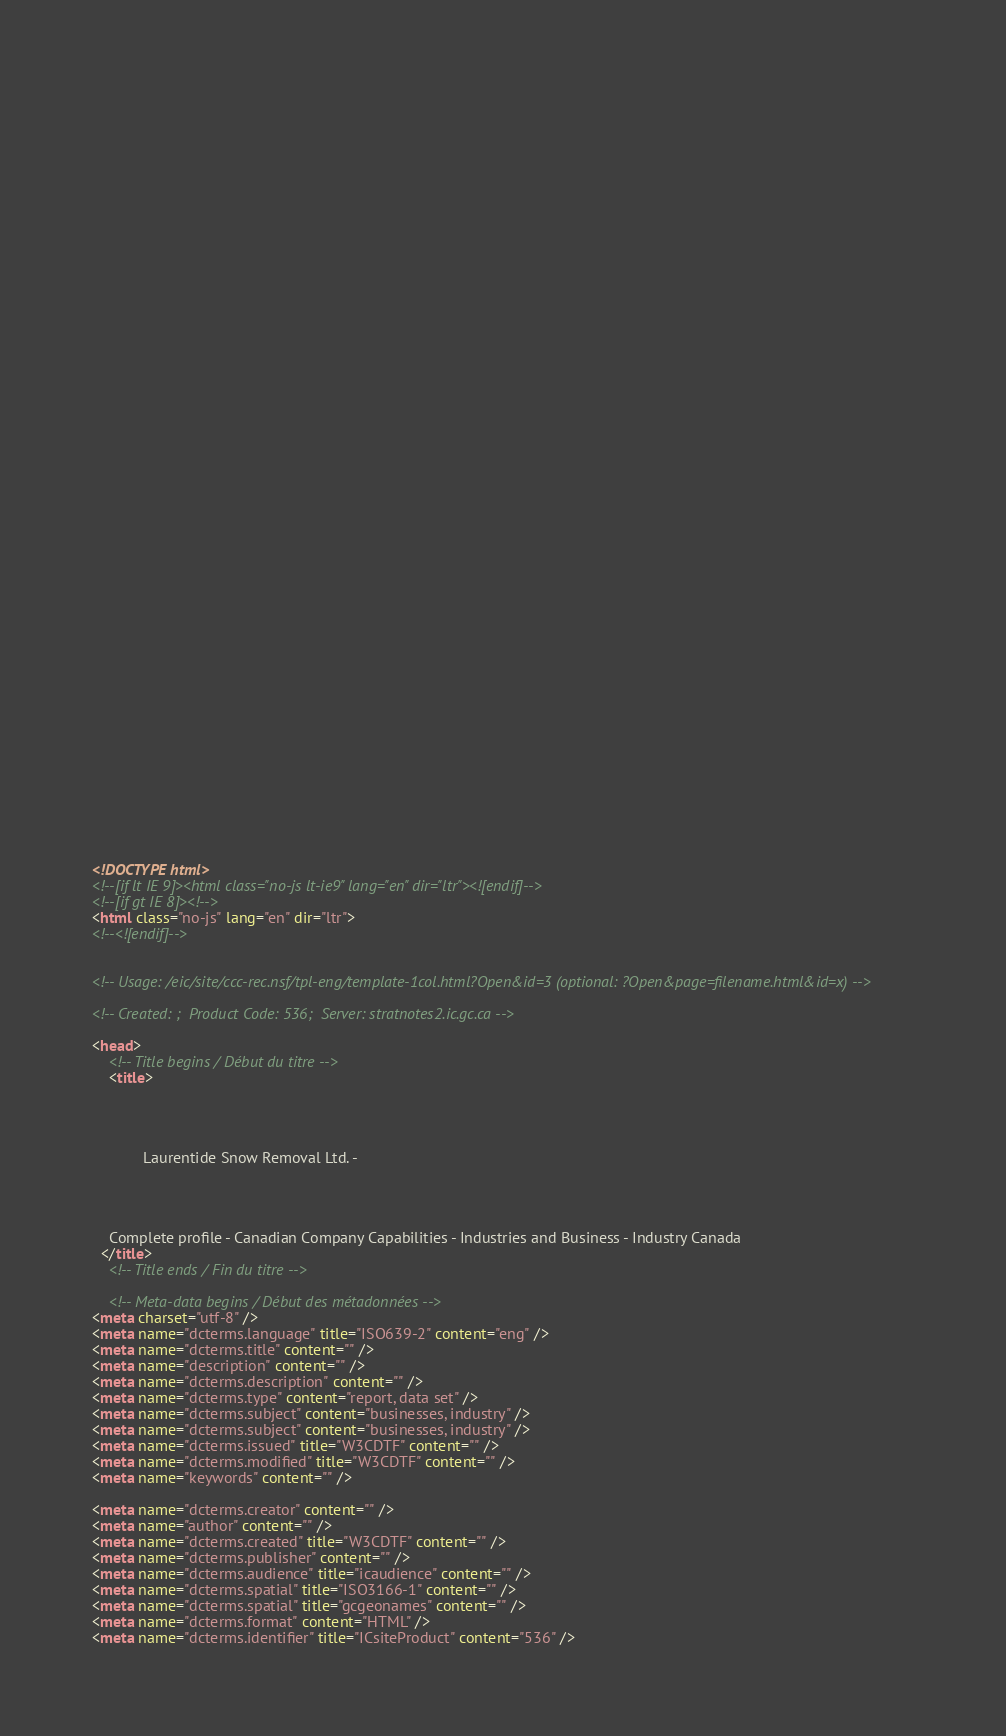<code> <loc_0><loc_0><loc_500><loc_500><_HTML_>


















	






  
  
  
  































	
	
	



<!DOCTYPE html>
<!--[if lt IE 9]><html class="no-js lt-ie9" lang="en" dir="ltr"><![endif]-->
<!--[if gt IE 8]><!-->
<html class="no-js" lang="en" dir="ltr">
<!--<![endif]-->


<!-- Usage: /eic/site/ccc-rec.nsf/tpl-eng/template-1col.html?Open&id=3 (optional: ?Open&page=filename.html&id=x) -->

<!-- Created: ;  Product Code: 536;  Server: stratnotes2.ic.gc.ca -->

<head>
	<!-- Title begins / Début du titre -->
	<title>
    
            
        
          
            Laurentide Snow Removal Ltd. -
          
        
      
    
    Complete profile - Canadian Company Capabilities - Industries and Business - Industry Canada
  </title>
	<!-- Title ends / Fin du titre -->
 
	<!-- Meta-data begins / Début des métadonnées -->
<meta charset="utf-8" />
<meta name="dcterms.language" title="ISO639-2" content="eng" />
<meta name="dcterms.title" content="" />
<meta name="description" content="" />
<meta name="dcterms.description" content="" />
<meta name="dcterms.type" content="report, data set" />
<meta name="dcterms.subject" content="businesses, industry" />
<meta name="dcterms.subject" content="businesses, industry" />
<meta name="dcterms.issued" title="W3CDTF" content="" />
<meta name="dcterms.modified" title="W3CDTF" content="" />
<meta name="keywords" content="" />

<meta name="dcterms.creator" content="" />
<meta name="author" content="" />
<meta name="dcterms.created" title="W3CDTF" content="" />
<meta name="dcterms.publisher" content="" />
<meta name="dcterms.audience" title="icaudience" content="" />
<meta name="dcterms.spatial" title="ISO3166-1" content="" />
<meta name="dcterms.spatial" title="gcgeonames" content="" />
<meta name="dcterms.format" content="HTML" />
<meta name="dcterms.identifier" title="ICsiteProduct" content="536" />
</code> 